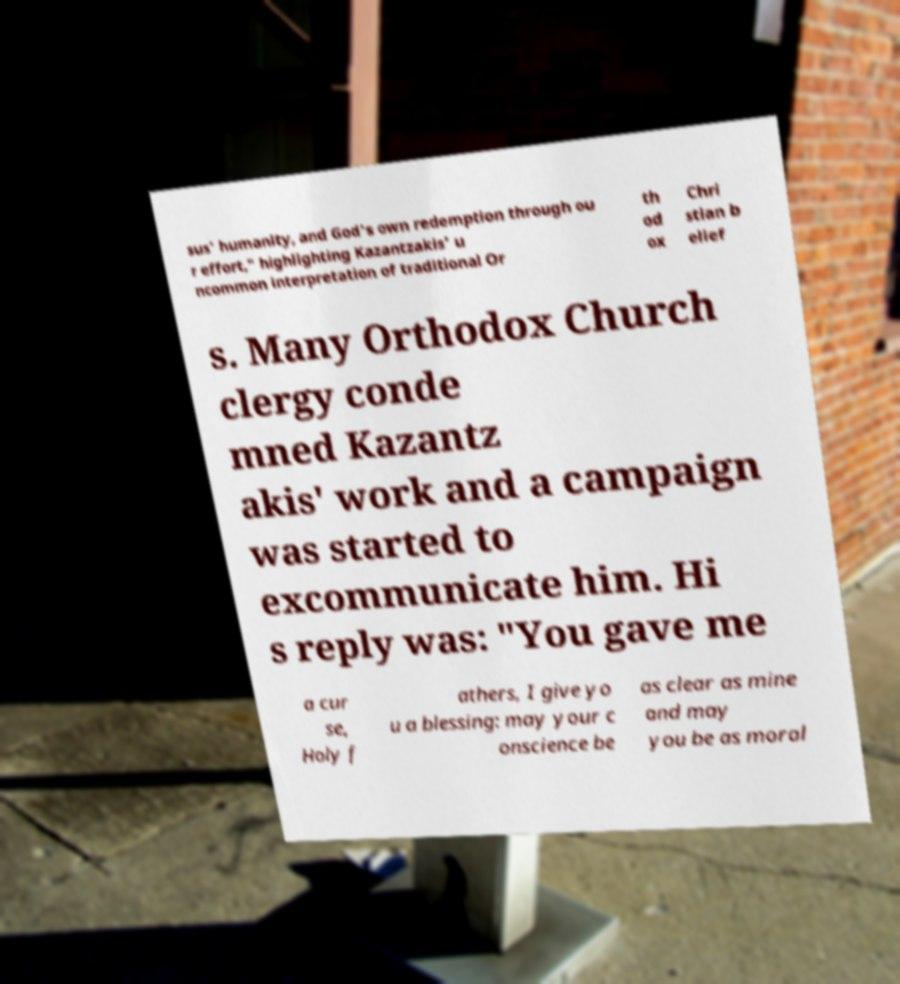Could you assist in decoding the text presented in this image and type it out clearly? sus' humanity, and God's own redemption through ou r effort," highlighting Kazantzakis' u ncommon interpretation of traditional Or th od ox Chri stian b elief s. Many Orthodox Church clergy conde mned Kazantz akis' work and a campaign was started to excommunicate him. Hi s reply was: "You gave me a cur se, Holy f athers, I give yo u a blessing: may your c onscience be as clear as mine and may you be as moral 